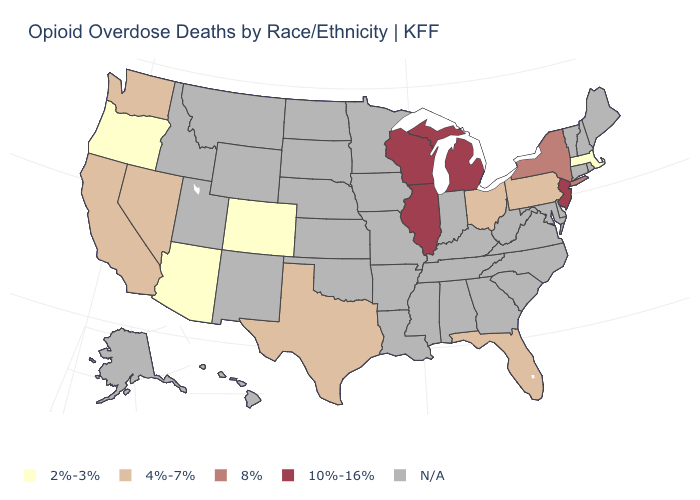What is the highest value in the MidWest ?
Answer briefly. 10%-16%. What is the value of Arkansas?
Short answer required. N/A. Name the states that have a value in the range 2%-3%?
Quick response, please. Arizona, Colorado, Massachusetts, Oregon. Name the states that have a value in the range 4%-7%?
Quick response, please. California, Florida, Nevada, Ohio, Pennsylvania, Texas, Washington. Name the states that have a value in the range 8%?
Keep it brief. New York. Among the states that border Washington , which have the lowest value?
Answer briefly. Oregon. What is the value of Virginia?
Be succinct. N/A. Name the states that have a value in the range 2%-3%?
Keep it brief. Arizona, Colorado, Massachusetts, Oregon. Does Colorado have the lowest value in the USA?
Give a very brief answer. Yes. What is the lowest value in the USA?
Write a very short answer. 2%-3%. What is the value of Connecticut?
Keep it brief. N/A. What is the lowest value in the Northeast?
Write a very short answer. 2%-3%. 